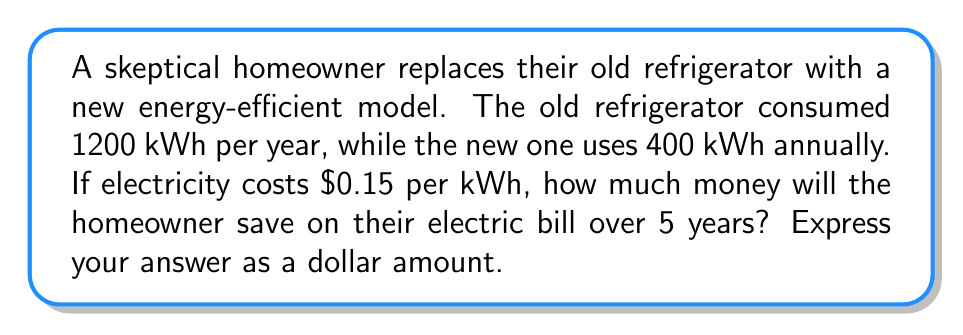Could you help me with this problem? Let's approach this step-by-step:

1. Calculate the difference in annual energy consumption:
   $$1200 \text{ kWh} - 400 \text{ kWh} = 800 \text{ kWh}$$

2. Calculate the annual cost savings:
   $$800 \text{ kWh} \times \$0.15/\text{kWh} = \$120$$

3. Calculate the savings over 5 years:
   $$\$120/\text{year} \times 5 \text{ years} = \$600$$

Therefore, over a 5-year period, the homeowner will save $600 on their electric bill by switching to the new energy-efficient refrigerator.
Answer: $600 